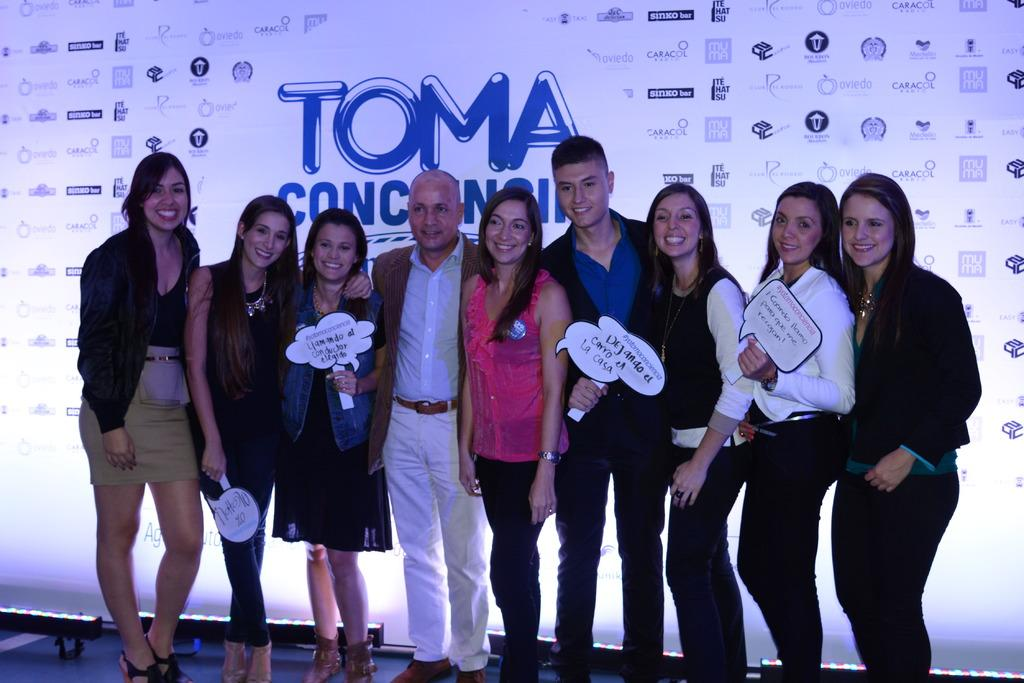How many people can be seen in the image? There are many persons standing on the ground in the image. What can be seen in the background of the image? There is an advertisement in the background of the image. What type of cake is being served to the snails in the image? There are no snails or cake present in the image. 